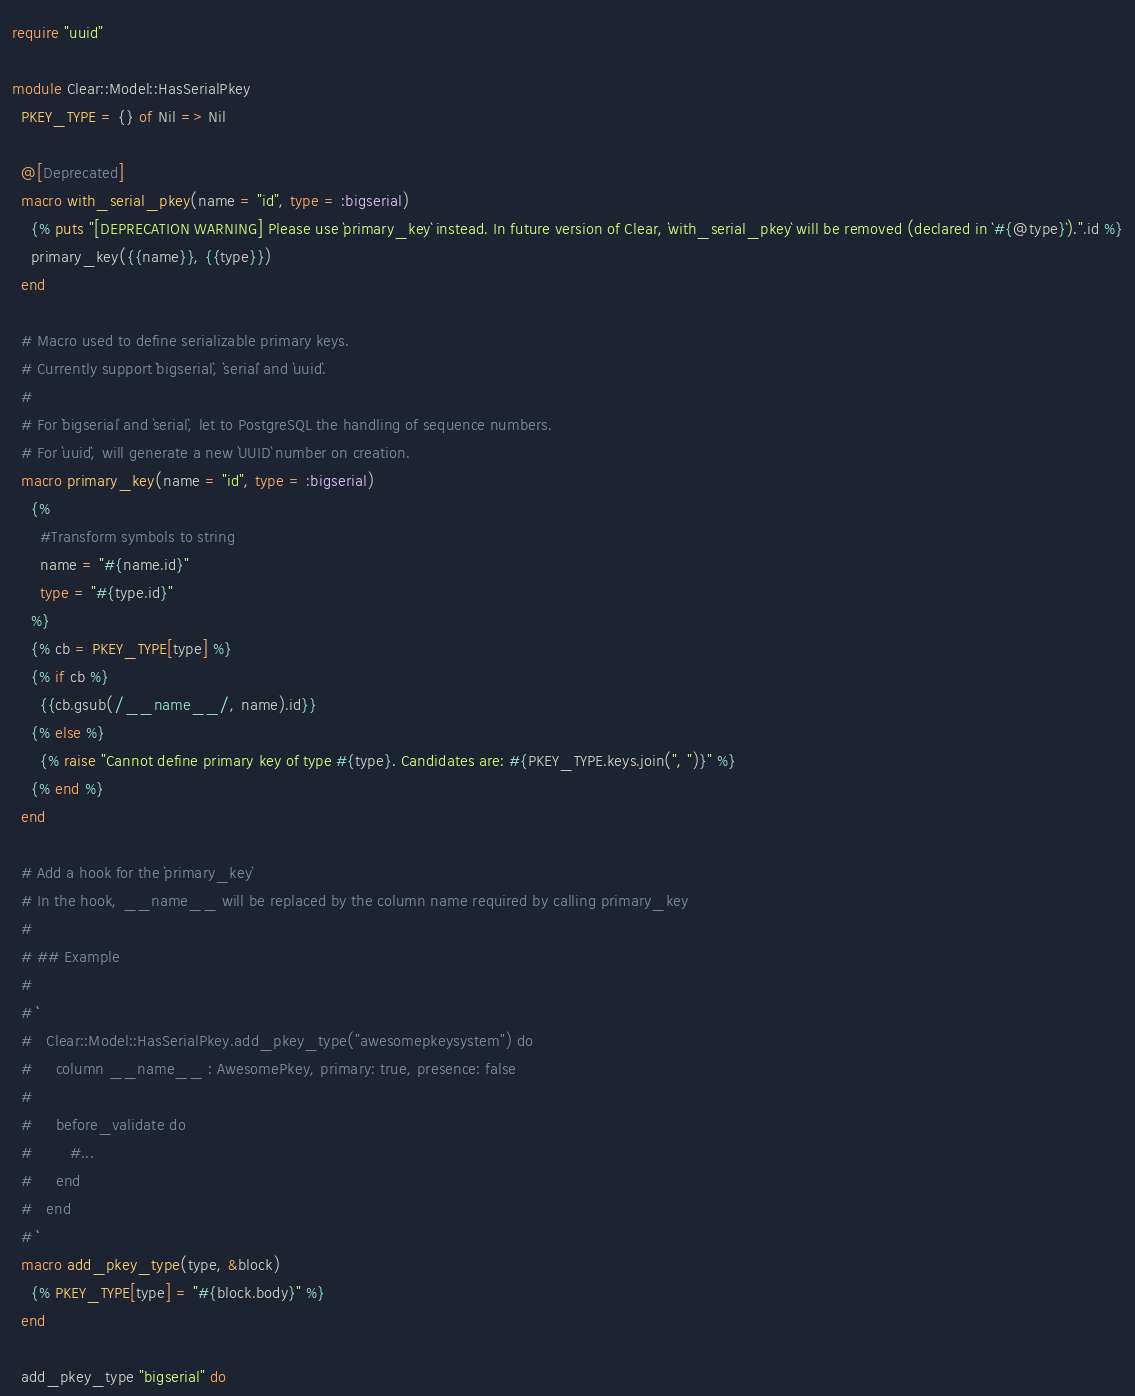Convert code to text. <code><loc_0><loc_0><loc_500><loc_500><_Crystal_>require "uuid"

module Clear::Model::HasSerialPkey
  PKEY_TYPE = {} of Nil => Nil

  @[Deprecated]
  macro with_serial_pkey(name = "id", type = :bigserial)
    {% puts "[DEPRECATION WARNING] Please use `primary_key` instead. In future version of Clear, `with_serial_pkey` will be removed (declared in `#{@type}`).".id %}
    primary_key({{name}}, {{type}})
  end

  # Macro used to define serializable primary keys.
  # Currently support `bigserial`, `serial` and `uuid`.
  #
  # For `bigserial` and `serial`, let to PostgreSQL the handling of sequence numbers.
  # For `uuid`, will generate a new `UUID` number on creation.
  macro primary_key(name = "id", type = :bigserial)
    {%
      #Transform symbols to string
      name = "#{name.id}"
      type = "#{type.id}"
    %}
    {% cb = PKEY_TYPE[type] %}
    {% if cb %}
      {{cb.gsub(/__name__/, name).id}}
    {% else %}
      {% raise "Cannot define primary key of type #{type}. Candidates are: #{PKEY_TYPE.keys.join(", ")}" %}
    {% end %}
  end

  # Add a hook for the `primary_key`
  # In the hook, __name__ will be replaced by the column name required by calling primary_key
  #
  # ## Example
  #
  # ```
  #   Clear::Model::HasSerialPkey.add_pkey_type("awesomepkeysystem") do
  #     column __name__ : AwesomePkey, primary: true, presence: false
  #
  #     before_validate do
  #        #...
  #     end
  #   end
  # ```
  macro add_pkey_type(type, &block)
    {% PKEY_TYPE[type] = "#{block.body}" %}
  end

  add_pkey_type "bigserial" do</code> 